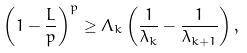Convert formula to latex. <formula><loc_0><loc_0><loc_500><loc_500>\left ( 1 - \frac { L } { p } \right ) ^ { p } \geq \Lambda _ { k } \left ( \frac { 1 } { \lambda _ { k } } - \frac { 1 } { \lambda _ { k + 1 } } \right ) ,</formula> 